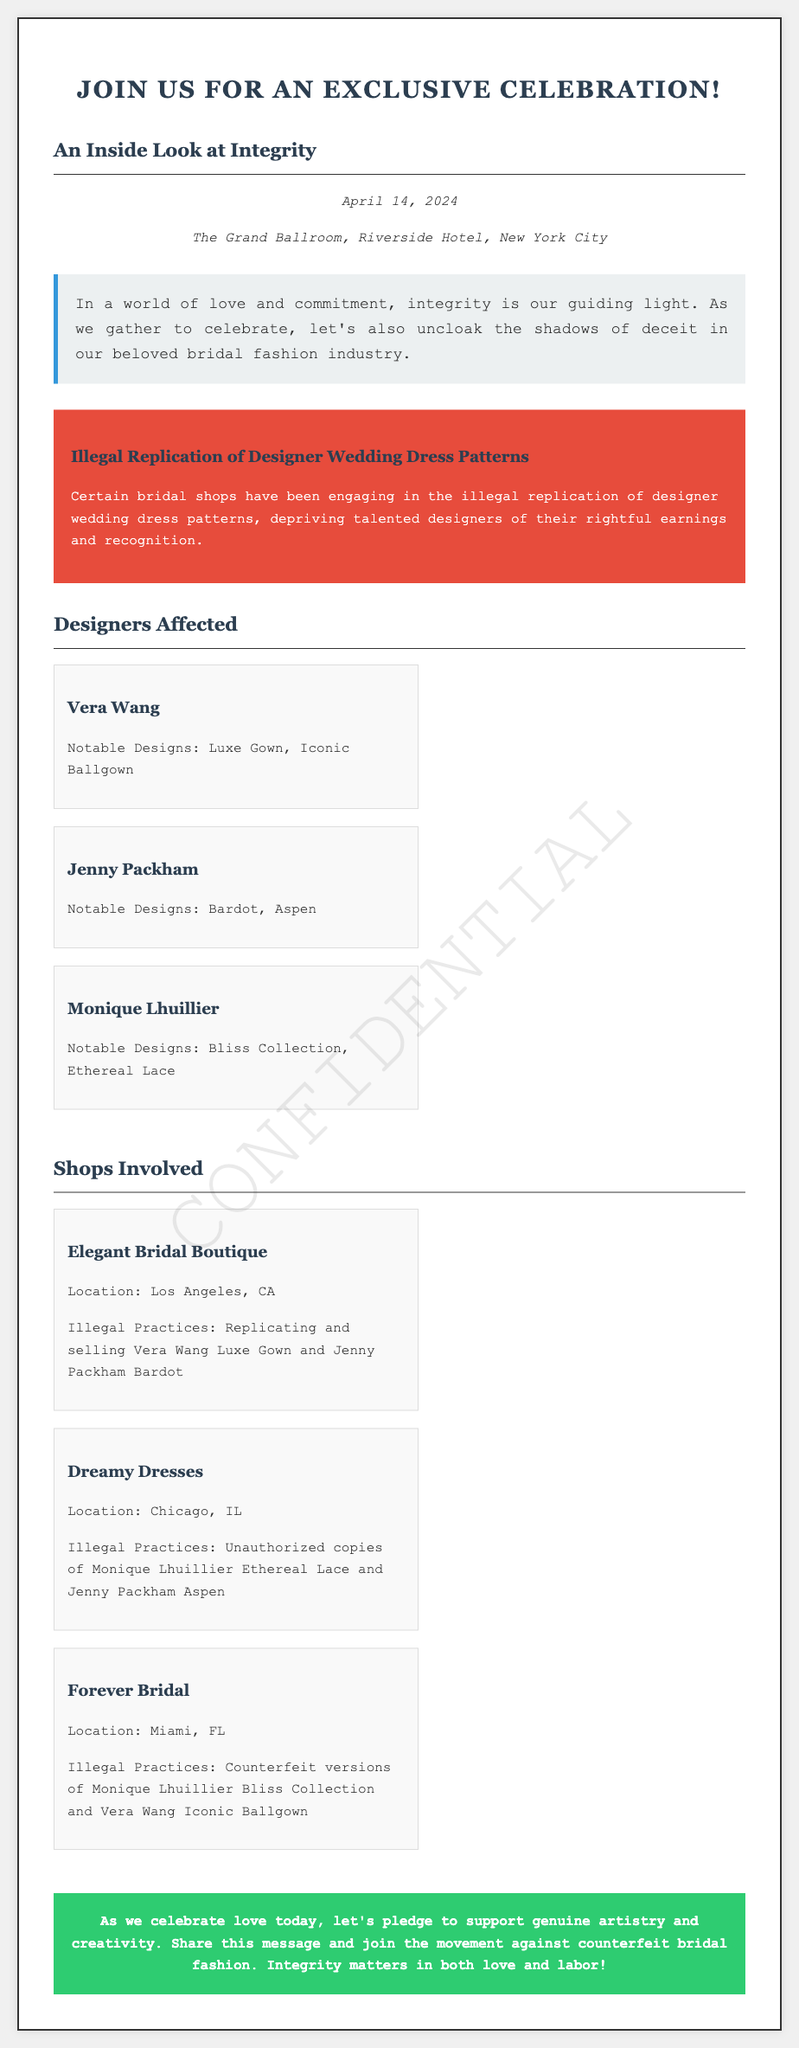What is the date of the wedding celebration? The date of the wedding celebration is explicitly mentioned in the document.
Answer: April 14, 2024 Where is the wedding celebration being held? The venue of the wedding celebration is provided in the document.
Answer: The Grand Ballroom, Riverside Hotel, New York City What designer is known for the Luxe Gown? The document specifies Vera Wang as the designer associated with the Luxe Gown.
Answer: Vera Wang Which bridal shop replicated the Vera Wang Luxe Gown? The document indicates which shop engaged in replicating this specific gown.
Answer: Elegant Bridal Boutique How many designers are listed as affected? The number of designers mentioned in the document can be found by counting the entries under the designers section.
Answer: Three What is the illegal practice associated with Dreamy Dresses? The document specifies the illegal practices linked to Dreamy Dresses.
Answer: Unauthorized copies of Monique Lhuillier Ethereal Lace and Jenny Packham Aspen What message is conveyed in the call-to-action section? The call-to-action summarizes the intention of the document and invites action.
Answer: Support genuine artistry and creativity Which city's shops are accused of wrongdoing? The document lists shops from different cities, asking for the specific cities involved indicates information retrieval.
Answer: Los Angeles, Chicago, Miami 